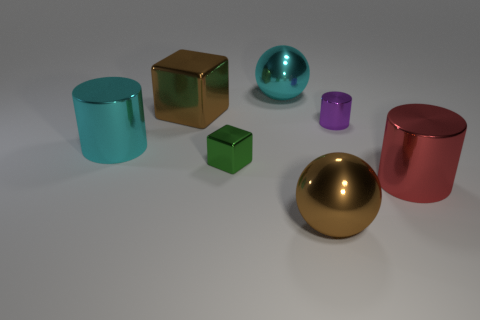Subtract all large cylinders. How many cylinders are left? 1 Subtract all green blocks. How many blocks are left? 1 Subtract all cubes. How many objects are left? 5 Add 1 metal things. How many objects exist? 8 Subtract 0 cyan cubes. How many objects are left? 7 Subtract 2 blocks. How many blocks are left? 0 Subtract all blue balls. Subtract all yellow blocks. How many balls are left? 2 Subtract all tiny brown objects. Subtract all cyan things. How many objects are left? 5 Add 5 small purple metal things. How many small purple metal things are left? 6 Add 5 big balls. How many big balls exist? 7 